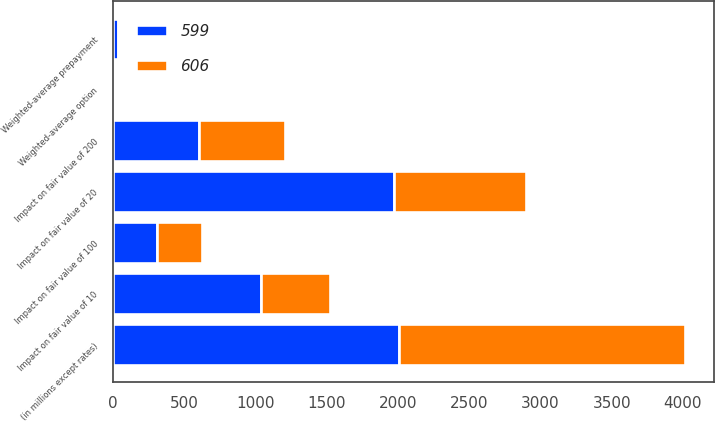<chart> <loc_0><loc_0><loc_500><loc_500><stacked_bar_chart><ecel><fcel>(in millions except rates)<fcel>Weighted-average prepayment<fcel>Impact on fair value of 10<fcel>Impact on fair value of 20<fcel>Weighted-average option<fcel>Impact on fair value of 100<fcel>Impact on fair value of 200<nl><fcel>599<fcel>2008<fcel>35.21<fcel>1039<fcel>1970<fcel>3.8<fcel>311<fcel>606<nl><fcel>606<fcel>2007<fcel>12.49<fcel>481<fcel>926<fcel>3<fcel>311<fcel>599<nl></chart> 